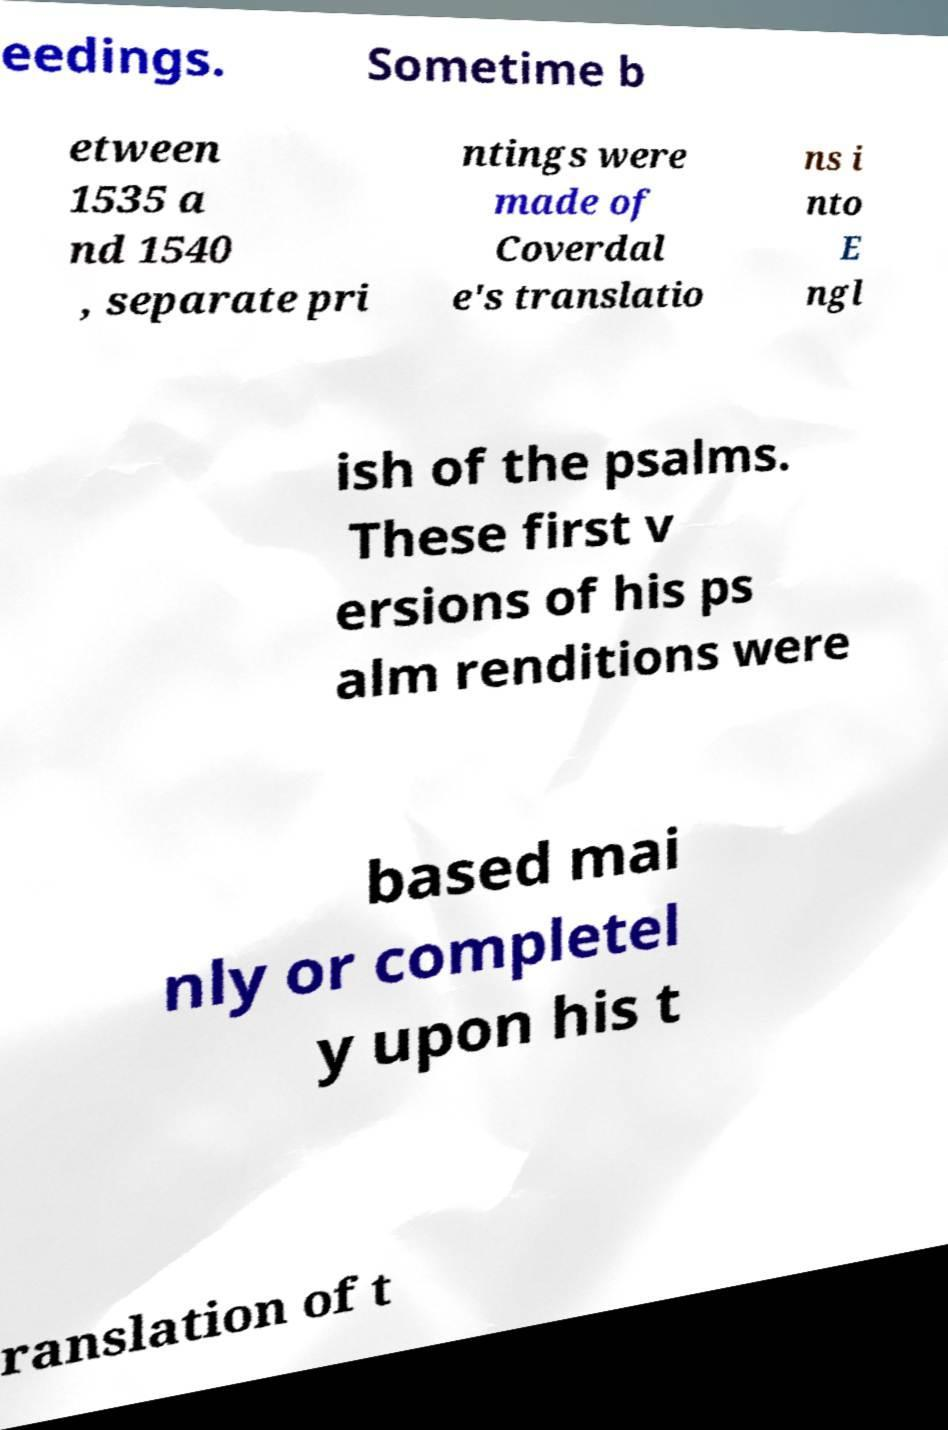Could you assist in decoding the text presented in this image and type it out clearly? eedings. Sometime b etween 1535 a nd 1540 , separate pri ntings were made of Coverdal e's translatio ns i nto E ngl ish of the psalms. These first v ersions of his ps alm renditions were based mai nly or completel y upon his t ranslation of t 